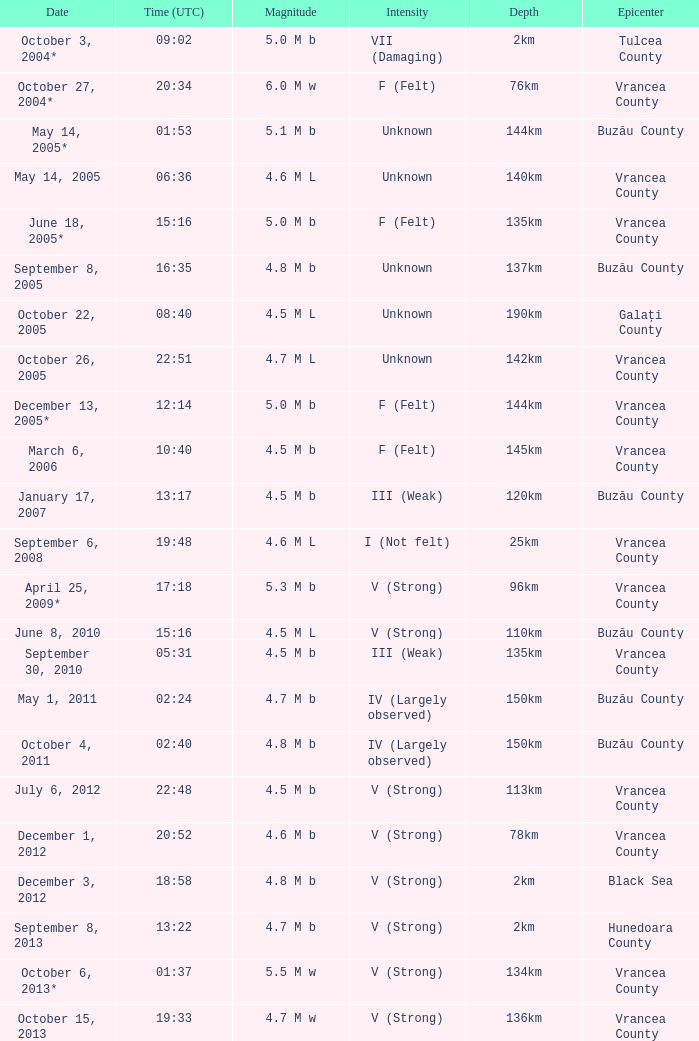What is the magnitude with epicenter at Vrancea County, unknown intensity and which happened at 06:36? 4.6 M L. 